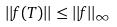<formula> <loc_0><loc_0><loc_500><loc_500>| | f ( T ) | | \leq | | f | | _ { \infty }</formula> 